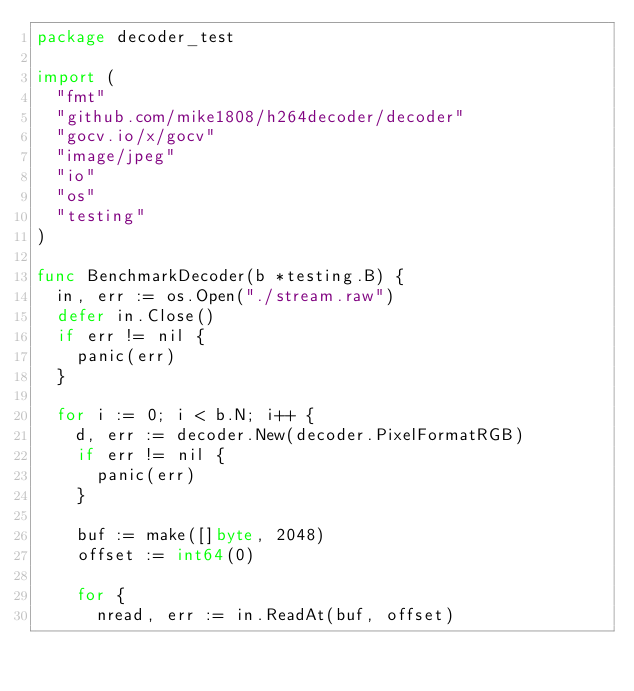Convert code to text. <code><loc_0><loc_0><loc_500><loc_500><_Go_>package decoder_test

import (
	"fmt"
	"github.com/mike1808/h264decoder/decoder"
	"gocv.io/x/gocv"
	"image/jpeg"
	"io"
	"os"
	"testing"
)

func BenchmarkDecoder(b *testing.B) {
	in, err := os.Open("./stream.raw")
	defer in.Close()
	if err != nil {
		panic(err)
	}

	for i := 0; i < b.N; i++ {
		d, err := decoder.New(decoder.PixelFormatRGB)
		if err != nil {
			panic(err)
		}

		buf := make([]byte, 2048)
		offset := int64(0)

		for {
			nread, err := in.ReadAt(buf, offset)</code> 